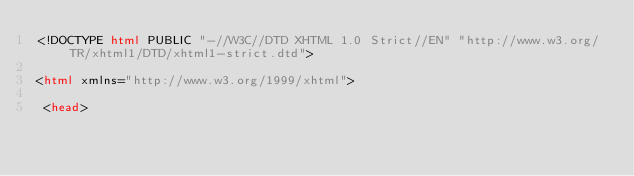Convert code to text. <code><loc_0><loc_0><loc_500><loc_500><_HTML_><!DOCTYPE html PUBLIC "-//W3C//DTD XHTML 1.0 Strict//EN" "http://www.w3.org/TR/xhtml1/DTD/xhtml1-strict.dtd">

<html xmlns="http://www.w3.org/1999/xhtml">

 <head>
</code> 